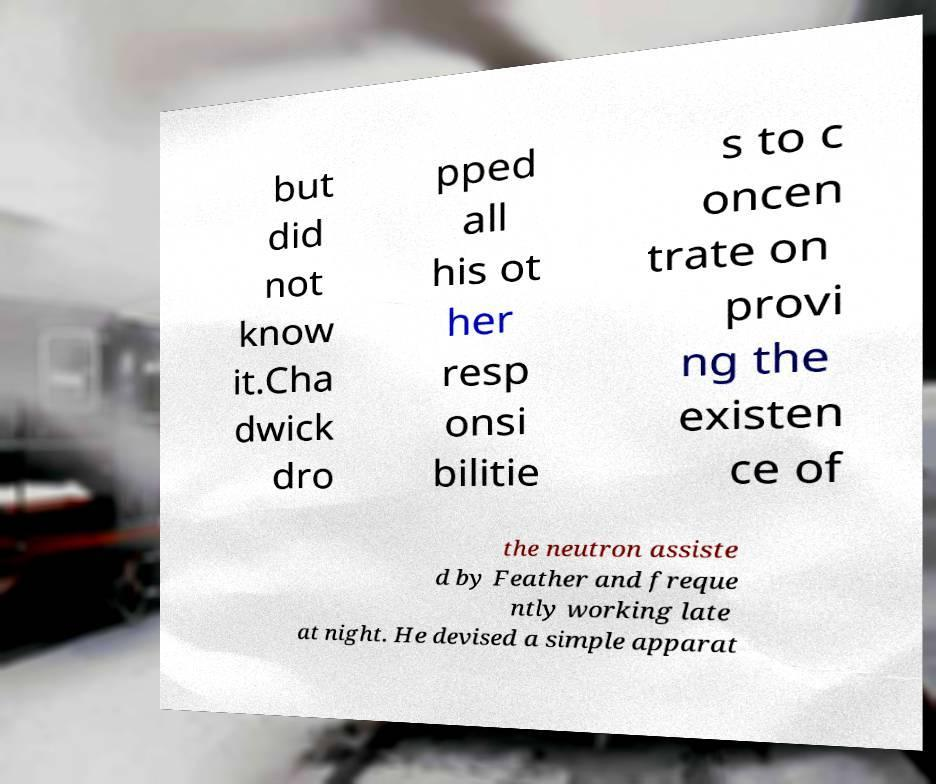Could you extract and type out the text from this image? but did not know it.Cha dwick dro pped all his ot her resp onsi bilitie s to c oncen trate on provi ng the existen ce of the neutron assiste d by Feather and freque ntly working late at night. He devised a simple apparat 